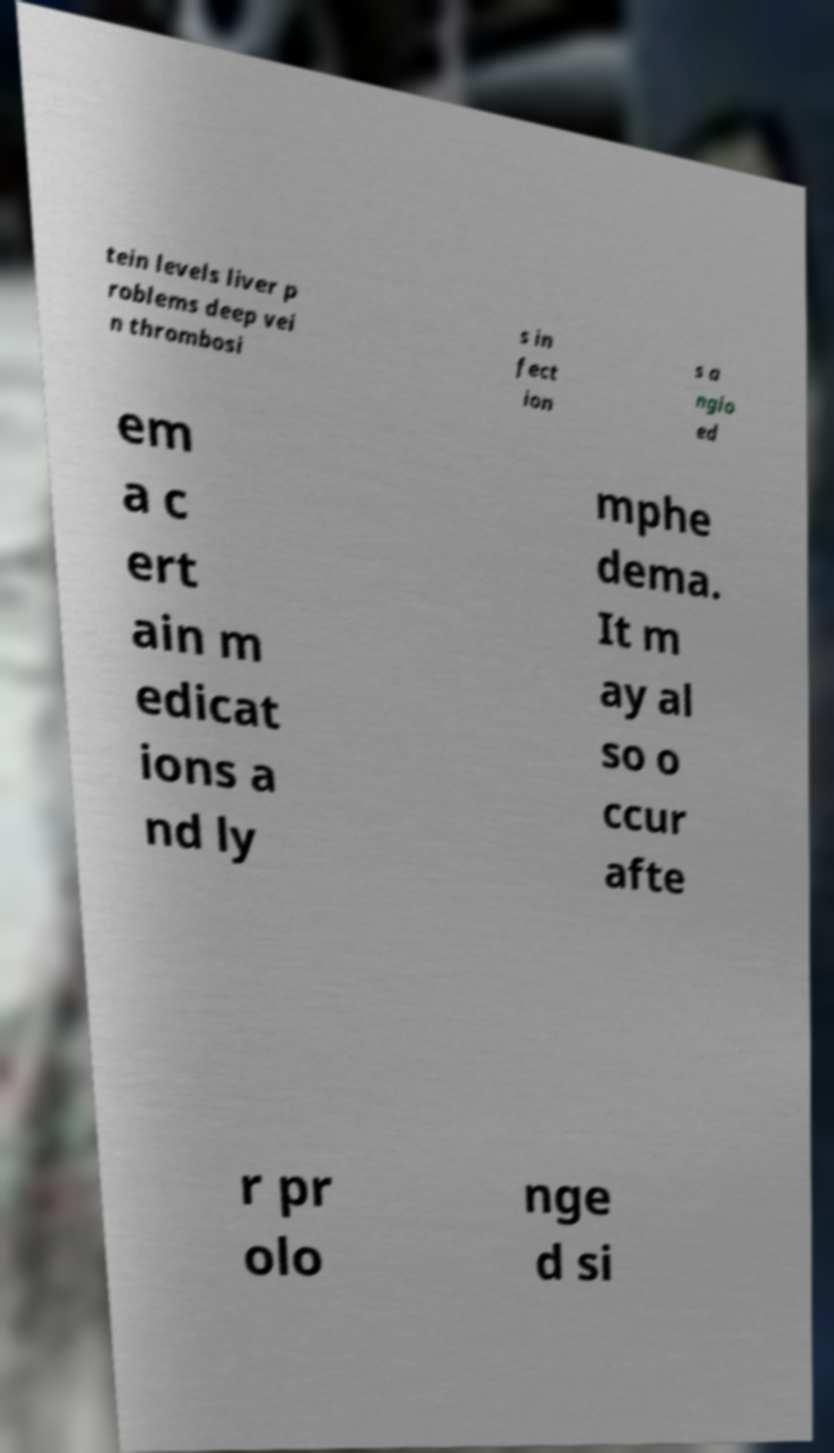For documentation purposes, I need the text within this image transcribed. Could you provide that? tein levels liver p roblems deep vei n thrombosi s in fect ion s a ngio ed em a c ert ain m edicat ions a nd ly mphe dema. It m ay al so o ccur afte r pr olo nge d si 